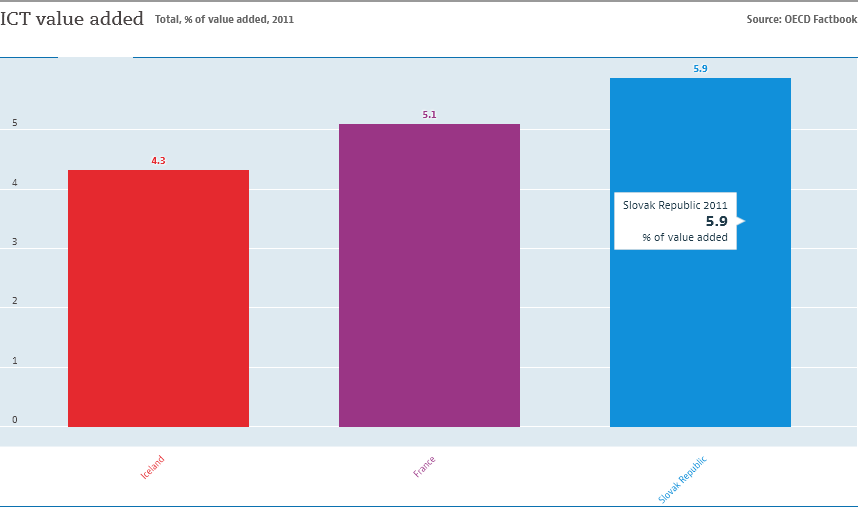Highlight a few significant elements in this photo. I would like to know the value of the blue bar, which is 5.9. The first two bars have a difference of 0.8. 